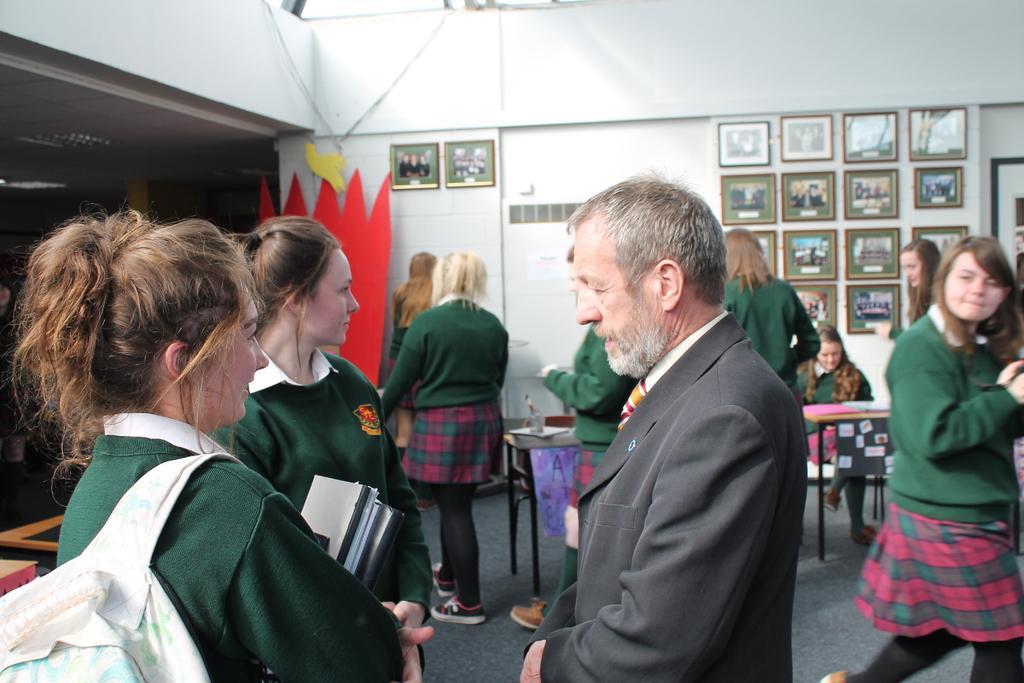Please provide a concise description of this image. In the middle of the image few people are standing. Behind them there is a table, on the table there are some papers and books. Behind the table a woman is sitting. Behind her there is a wall, on the wall there are some frames. 